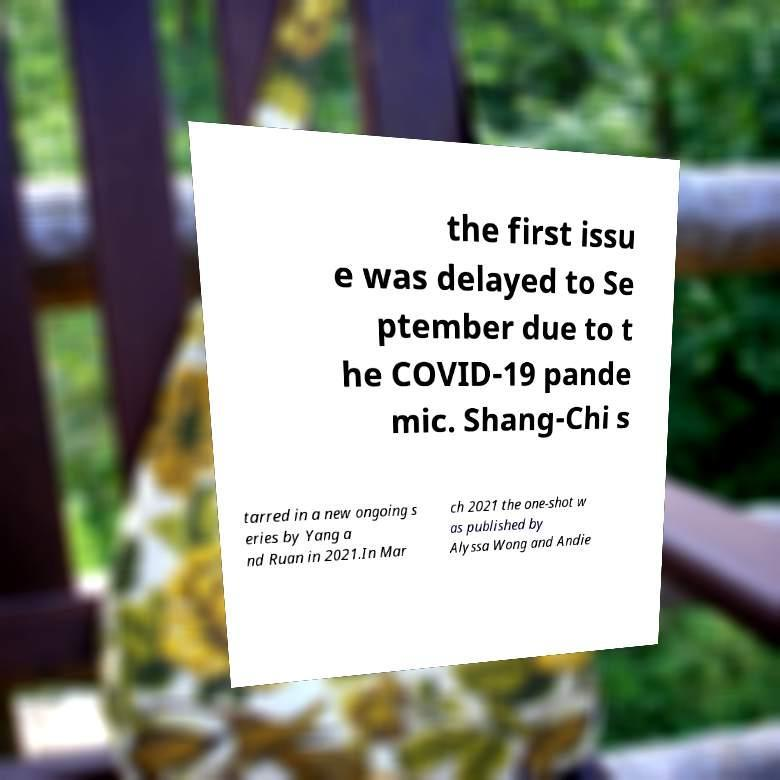Could you assist in decoding the text presented in this image and type it out clearly? the first issu e was delayed to Se ptember due to t he COVID-19 pande mic. Shang-Chi s tarred in a new ongoing s eries by Yang a nd Ruan in 2021.In Mar ch 2021 the one-shot w as published by Alyssa Wong and Andie 